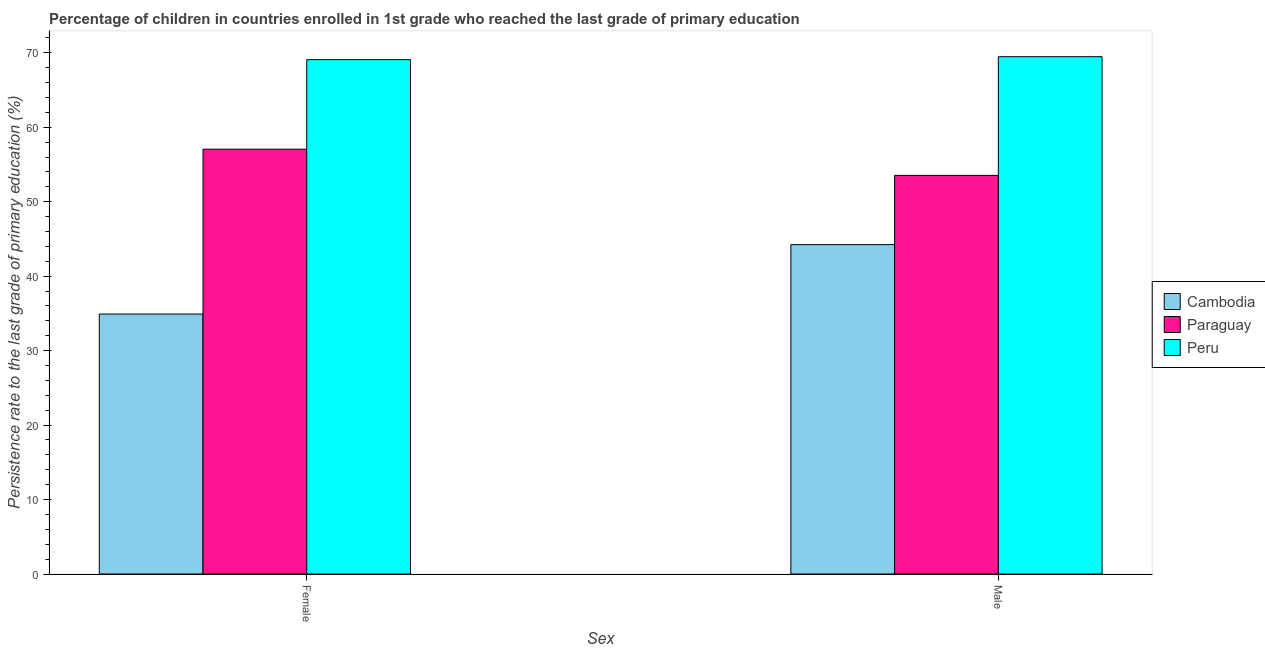How many different coloured bars are there?
Offer a terse response. 3. How many groups of bars are there?
Offer a very short reply. 2. Are the number of bars on each tick of the X-axis equal?
Your answer should be compact. Yes. What is the persistence rate of female students in Paraguay?
Your response must be concise. 57.05. Across all countries, what is the maximum persistence rate of male students?
Ensure brevity in your answer.  69.47. Across all countries, what is the minimum persistence rate of female students?
Provide a short and direct response. 34.91. In which country was the persistence rate of female students maximum?
Your response must be concise. Peru. In which country was the persistence rate of female students minimum?
Provide a succinct answer. Cambodia. What is the total persistence rate of male students in the graph?
Provide a succinct answer. 167.23. What is the difference between the persistence rate of female students in Peru and that in Paraguay?
Give a very brief answer. 12.02. What is the difference between the persistence rate of female students in Cambodia and the persistence rate of male students in Peru?
Make the answer very short. -34.56. What is the average persistence rate of male students per country?
Your response must be concise. 55.74. What is the difference between the persistence rate of male students and persistence rate of female students in Paraguay?
Your answer should be very brief. -3.52. What is the ratio of the persistence rate of male students in Peru to that in Cambodia?
Give a very brief answer. 1.57. Is the persistence rate of female students in Paraguay less than that in Peru?
Give a very brief answer. Yes. What does the 2nd bar from the left in Male represents?
Provide a succinct answer. Paraguay. What does the 1st bar from the right in Female represents?
Give a very brief answer. Peru. How many bars are there?
Your answer should be compact. 6. Are all the bars in the graph horizontal?
Provide a succinct answer. No. Are the values on the major ticks of Y-axis written in scientific E-notation?
Keep it short and to the point. No. Does the graph contain grids?
Your response must be concise. No. How are the legend labels stacked?
Your response must be concise. Vertical. What is the title of the graph?
Provide a succinct answer. Percentage of children in countries enrolled in 1st grade who reached the last grade of primary education. Does "Angola" appear as one of the legend labels in the graph?
Your response must be concise. No. What is the label or title of the X-axis?
Ensure brevity in your answer.  Sex. What is the label or title of the Y-axis?
Keep it short and to the point. Persistence rate to the last grade of primary education (%). What is the Persistence rate to the last grade of primary education (%) in Cambodia in Female?
Offer a terse response. 34.91. What is the Persistence rate to the last grade of primary education (%) in Paraguay in Female?
Your response must be concise. 57.05. What is the Persistence rate to the last grade of primary education (%) in Peru in Female?
Keep it short and to the point. 69.07. What is the Persistence rate to the last grade of primary education (%) of Cambodia in Male?
Your answer should be very brief. 44.23. What is the Persistence rate to the last grade of primary education (%) of Paraguay in Male?
Make the answer very short. 53.53. What is the Persistence rate to the last grade of primary education (%) of Peru in Male?
Your answer should be very brief. 69.47. Across all Sex, what is the maximum Persistence rate to the last grade of primary education (%) of Cambodia?
Provide a short and direct response. 44.23. Across all Sex, what is the maximum Persistence rate to the last grade of primary education (%) in Paraguay?
Make the answer very short. 57.05. Across all Sex, what is the maximum Persistence rate to the last grade of primary education (%) in Peru?
Keep it short and to the point. 69.47. Across all Sex, what is the minimum Persistence rate to the last grade of primary education (%) of Cambodia?
Your answer should be very brief. 34.91. Across all Sex, what is the minimum Persistence rate to the last grade of primary education (%) in Paraguay?
Your response must be concise. 53.53. Across all Sex, what is the minimum Persistence rate to the last grade of primary education (%) in Peru?
Your response must be concise. 69.07. What is the total Persistence rate to the last grade of primary education (%) in Cambodia in the graph?
Your answer should be compact. 79.15. What is the total Persistence rate to the last grade of primary education (%) in Paraguay in the graph?
Keep it short and to the point. 110.58. What is the total Persistence rate to the last grade of primary education (%) in Peru in the graph?
Make the answer very short. 138.55. What is the difference between the Persistence rate to the last grade of primary education (%) in Cambodia in Female and that in Male?
Provide a succinct answer. -9.32. What is the difference between the Persistence rate to the last grade of primary education (%) of Paraguay in Female and that in Male?
Provide a short and direct response. 3.52. What is the difference between the Persistence rate to the last grade of primary education (%) of Peru in Female and that in Male?
Your response must be concise. -0.4. What is the difference between the Persistence rate to the last grade of primary education (%) in Cambodia in Female and the Persistence rate to the last grade of primary education (%) in Paraguay in Male?
Ensure brevity in your answer.  -18.62. What is the difference between the Persistence rate to the last grade of primary education (%) of Cambodia in Female and the Persistence rate to the last grade of primary education (%) of Peru in Male?
Ensure brevity in your answer.  -34.56. What is the difference between the Persistence rate to the last grade of primary education (%) in Paraguay in Female and the Persistence rate to the last grade of primary education (%) in Peru in Male?
Your answer should be compact. -12.42. What is the average Persistence rate to the last grade of primary education (%) of Cambodia per Sex?
Keep it short and to the point. 39.57. What is the average Persistence rate to the last grade of primary education (%) in Paraguay per Sex?
Ensure brevity in your answer.  55.29. What is the average Persistence rate to the last grade of primary education (%) of Peru per Sex?
Your answer should be compact. 69.27. What is the difference between the Persistence rate to the last grade of primary education (%) of Cambodia and Persistence rate to the last grade of primary education (%) of Paraguay in Female?
Offer a very short reply. -22.14. What is the difference between the Persistence rate to the last grade of primary education (%) of Cambodia and Persistence rate to the last grade of primary education (%) of Peru in Female?
Keep it short and to the point. -34.16. What is the difference between the Persistence rate to the last grade of primary education (%) of Paraguay and Persistence rate to the last grade of primary education (%) of Peru in Female?
Keep it short and to the point. -12.02. What is the difference between the Persistence rate to the last grade of primary education (%) of Cambodia and Persistence rate to the last grade of primary education (%) of Paraguay in Male?
Your answer should be very brief. -9.29. What is the difference between the Persistence rate to the last grade of primary education (%) of Cambodia and Persistence rate to the last grade of primary education (%) of Peru in Male?
Your answer should be very brief. -25.24. What is the difference between the Persistence rate to the last grade of primary education (%) in Paraguay and Persistence rate to the last grade of primary education (%) in Peru in Male?
Your answer should be very brief. -15.94. What is the ratio of the Persistence rate to the last grade of primary education (%) of Cambodia in Female to that in Male?
Give a very brief answer. 0.79. What is the ratio of the Persistence rate to the last grade of primary education (%) in Paraguay in Female to that in Male?
Your answer should be compact. 1.07. What is the difference between the highest and the second highest Persistence rate to the last grade of primary education (%) of Cambodia?
Your answer should be compact. 9.32. What is the difference between the highest and the second highest Persistence rate to the last grade of primary education (%) of Paraguay?
Your response must be concise. 3.52. What is the difference between the highest and the second highest Persistence rate to the last grade of primary education (%) in Peru?
Provide a succinct answer. 0.4. What is the difference between the highest and the lowest Persistence rate to the last grade of primary education (%) in Cambodia?
Provide a succinct answer. 9.32. What is the difference between the highest and the lowest Persistence rate to the last grade of primary education (%) of Paraguay?
Your response must be concise. 3.52. What is the difference between the highest and the lowest Persistence rate to the last grade of primary education (%) of Peru?
Give a very brief answer. 0.4. 